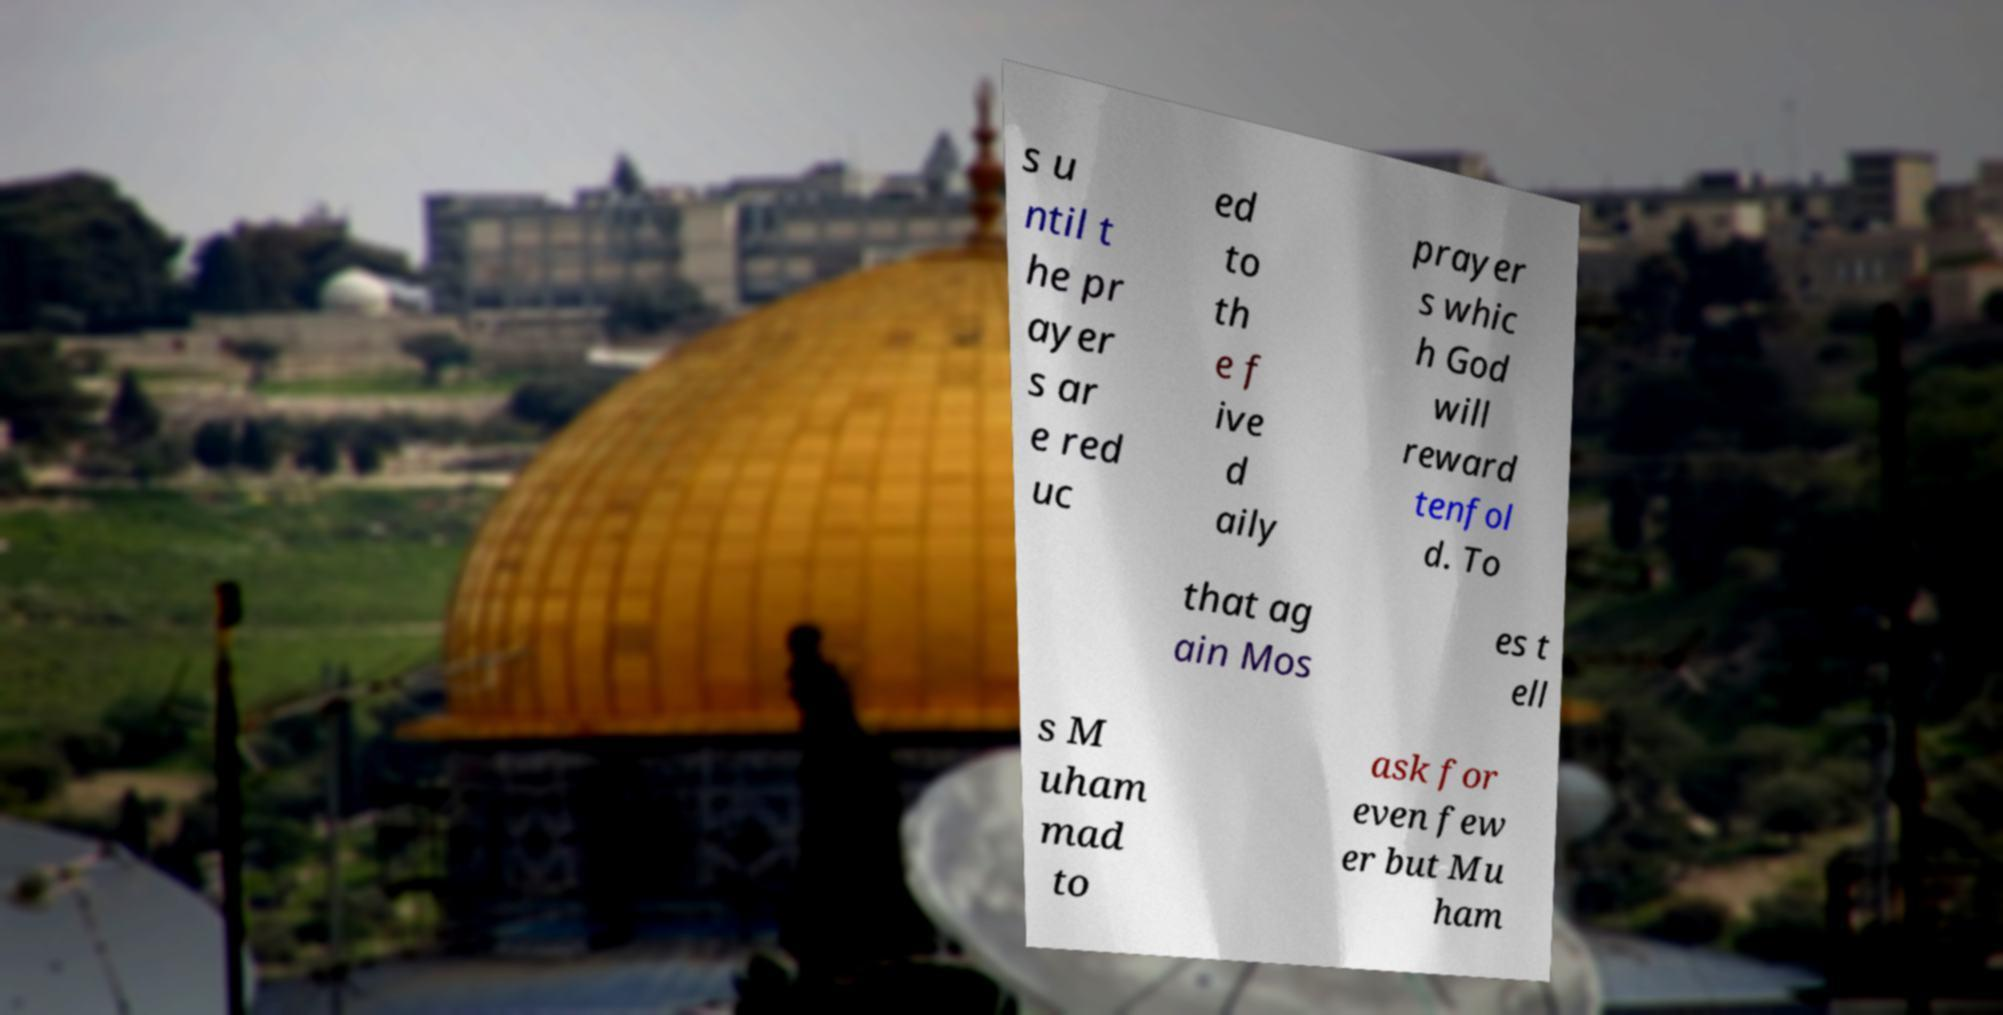There's text embedded in this image that I need extracted. Can you transcribe it verbatim? s u ntil t he pr ayer s ar e red uc ed to th e f ive d aily prayer s whic h God will reward tenfol d. To that ag ain Mos es t ell s M uham mad to ask for even few er but Mu ham 